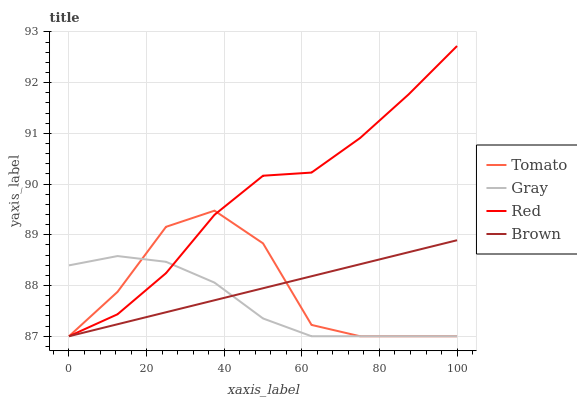Does Gray have the minimum area under the curve?
Answer yes or no. Yes. Does Red have the maximum area under the curve?
Answer yes or no. Yes. Does Red have the minimum area under the curve?
Answer yes or no. No. Does Gray have the maximum area under the curve?
Answer yes or no. No. Is Brown the smoothest?
Answer yes or no. Yes. Is Tomato the roughest?
Answer yes or no. Yes. Is Gray the smoothest?
Answer yes or no. No. Is Gray the roughest?
Answer yes or no. No. Does Red have the highest value?
Answer yes or no. Yes. Does Gray have the highest value?
Answer yes or no. No. Does Red intersect Gray?
Answer yes or no. Yes. Is Red less than Gray?
Answer yes or no. No. Is Red greater than Gray?
Answer yes or no. No. 